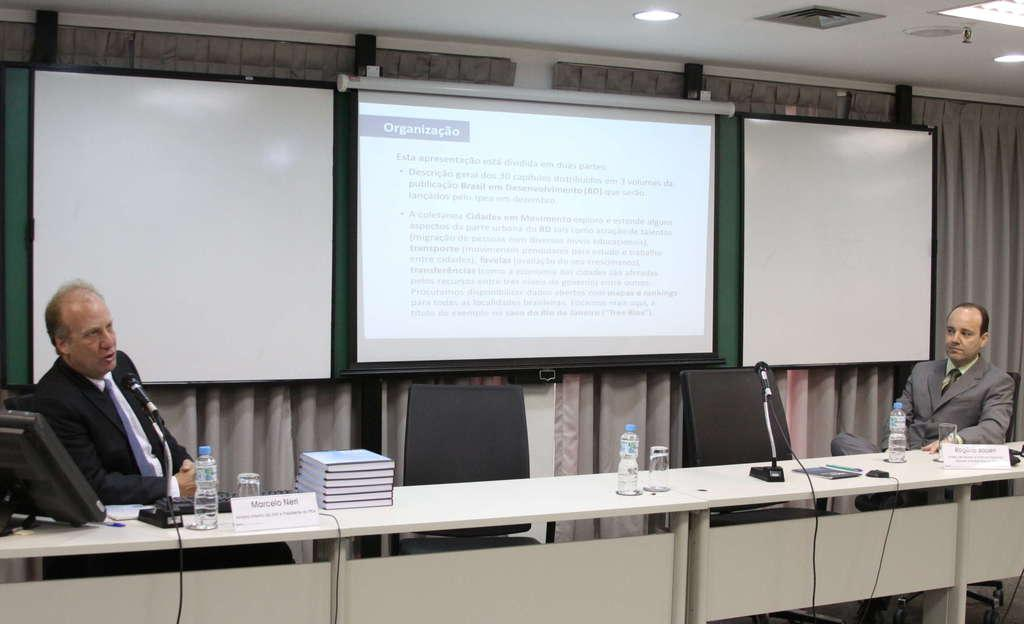How many people are in the image? There are two men in the image. What are the men doing in the image? The men are sitting on chairs. What is on the table in the image? There is a book, a glass, and a water bottle on the table. What objects are used for communication in the image? There are microphones in the image. What is visible in the background of the image? There is a white screen in the background. What type of pen is the woman using to write on the white screen in the image? There is no woman present in the image, and therefore no pen or writing on the white screen. 